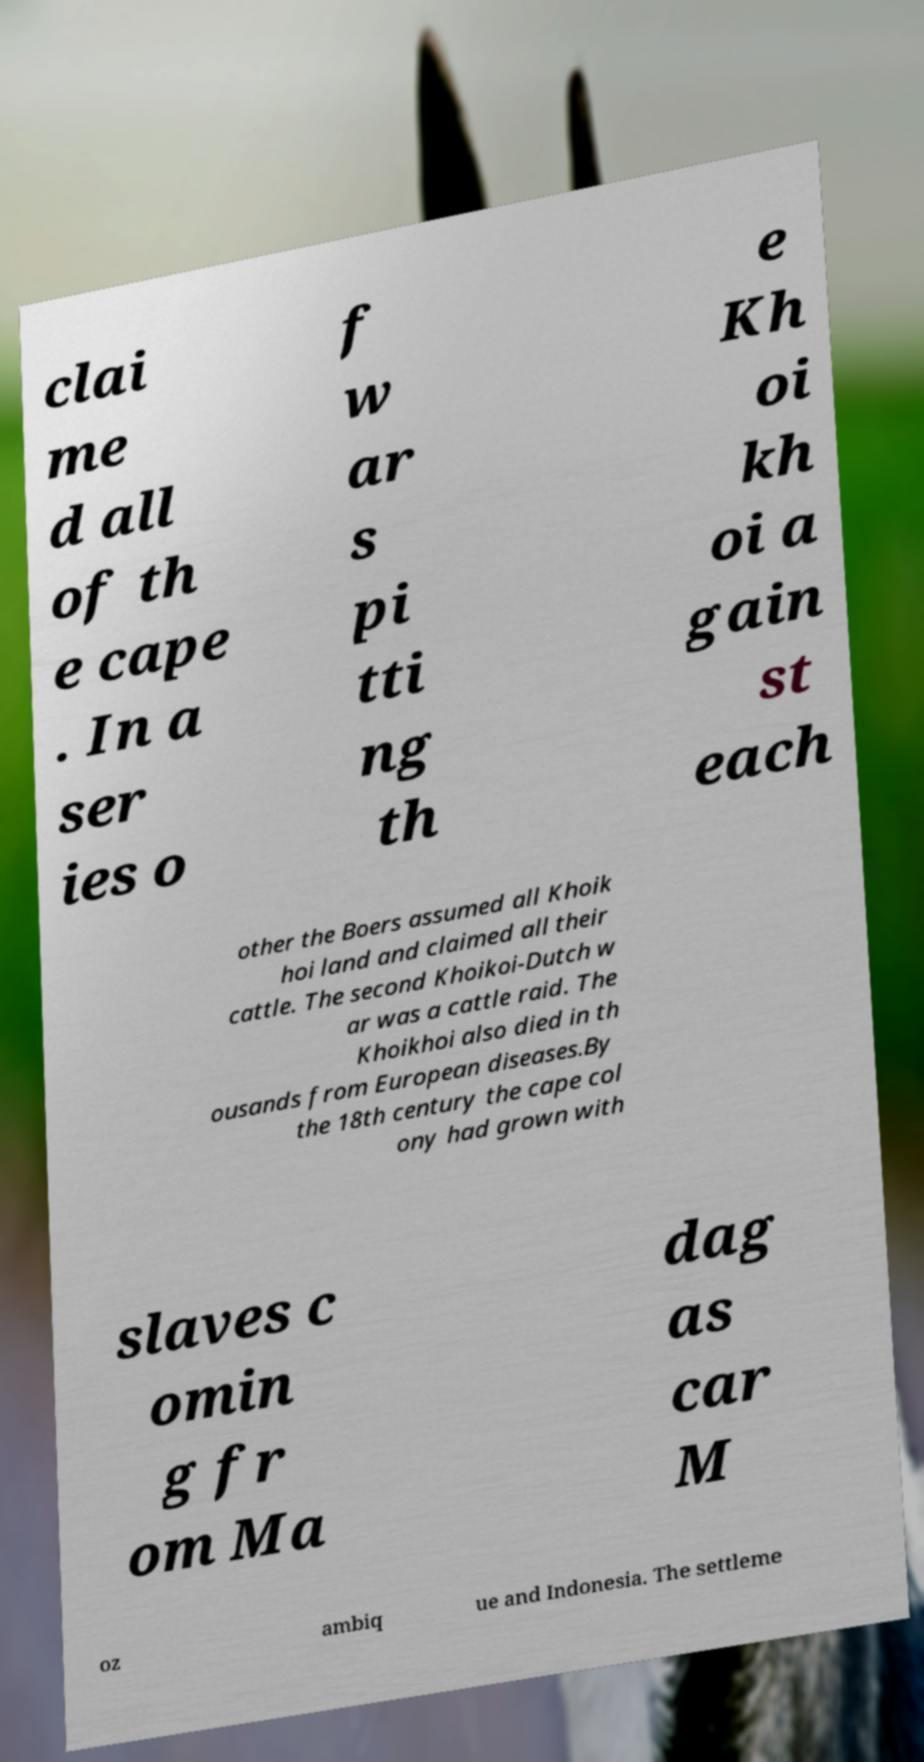For documentation purposes, I need the text within this image transcribed. Could you provide that? clai me d all of th e cape . In a ser ies o f w ar s pi tti ng th e Kh oi kh oi a gain st each other the Boers assumed all Khoik hoi land and claimed all their cattle. The second Khoikoi-Dutch w ar was a cattle raid. The Khoikhoi also died in th ousands from European diseases.By the 18th century the cape col ony had grown with slaves c omin g fr om Ma dag as car M oz ambiq ue and Indonesia. The settleme 